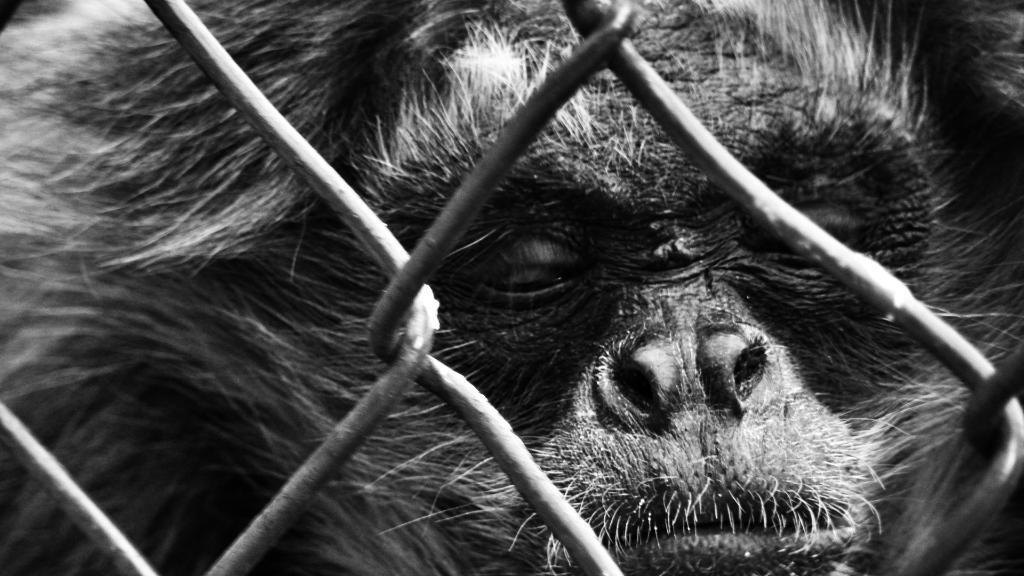Please provide a concise description of this image. In this image, we can see a chimpanzee and we can see some rods. 